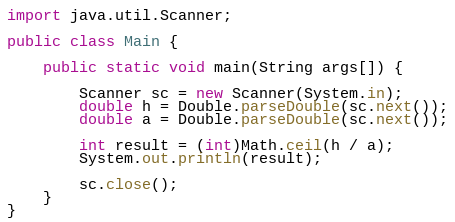<code> <loc_0><loc_0><loc_500><loc_500><_Java_>import java.util.Scanner;

public class Main {

    public static void main(String args[]) {

        Scanner sc = new Scanner(System.in);
        double h = Double.parseDouble(sc.next());
        double a = Double.parseDouble(sc.next());

        int result = (int)Math.ceil(h / a);
        System.out.println(result);

        sc.close();
    }
}
</code> 